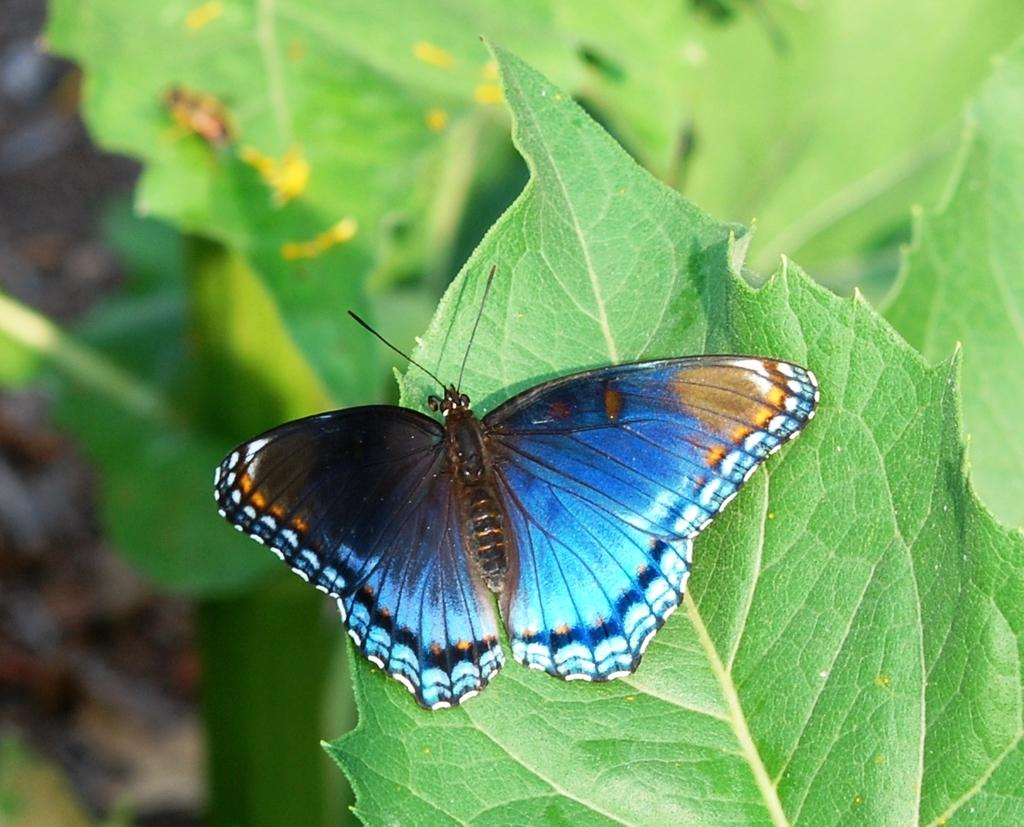What is the main subject of the image? There is a butterfly in the image. Can you describe the colors of the butterfly? The butterfly has blue, black, and white colors. Where is the butterfly located in the image? The butterfly is on a leaf. What is the color of the background in the image? The background of the image is green. What type of nut can be seen in the image? There is no nut present in the image; it features a butterfly on a leaf with a green background. What discovery was made by the hen in the image? There is no hen present in the image, so no discovery can be attributed to a hen. 